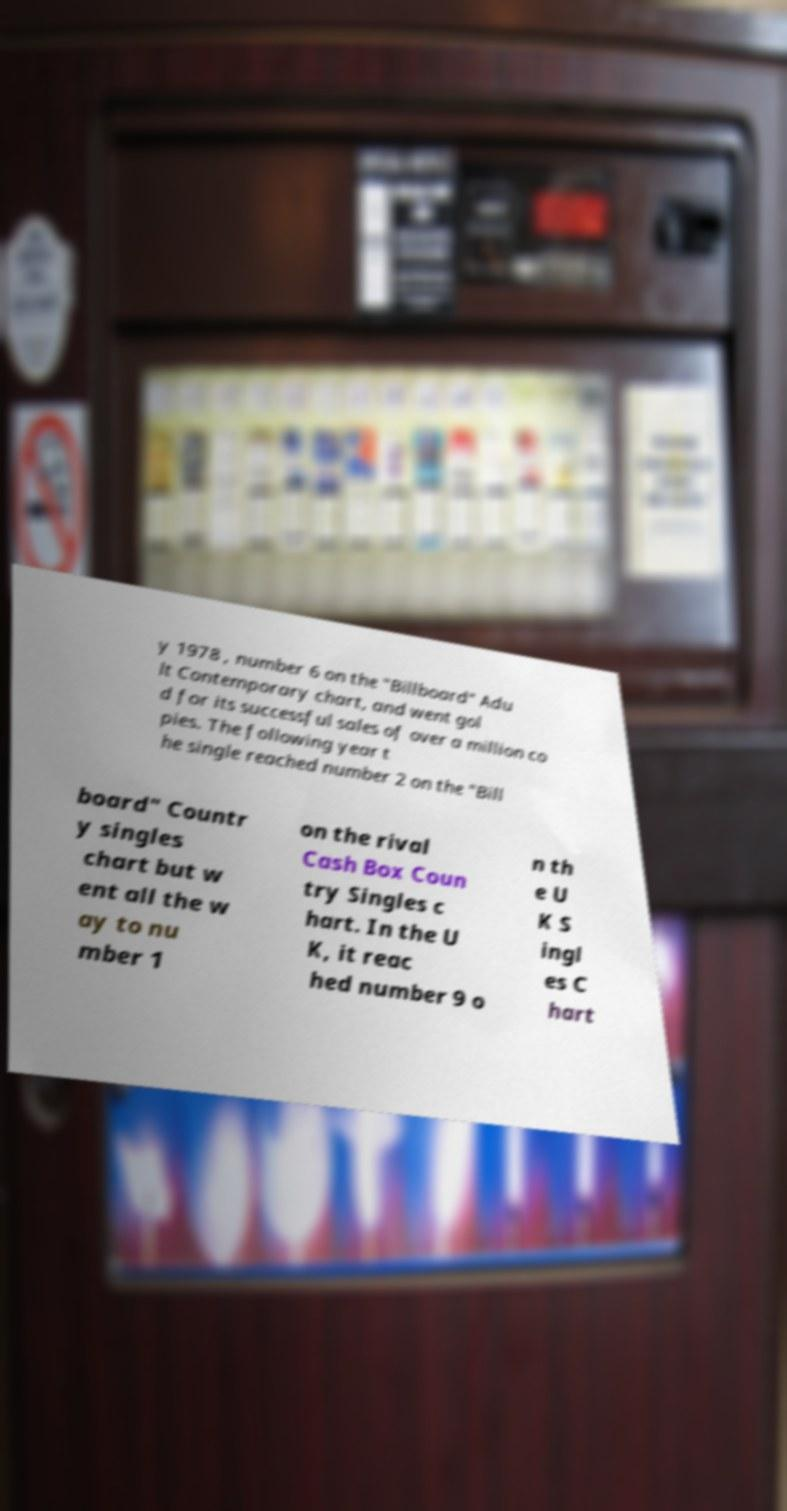Can you accurately transcribe the text from the provided image for me? y 1978 , number 6 on the "Billboard" Adu lt Contemporary chart, and went gol d for its successful sales of over a million co pies. The following year t he single reached number 2 on the "Bill board" Countr y singles chart but w ent all the w ay to nu mber 1 on the rival Cash Box Coun try Singles c hart. In the U K, it reac hed number 9 o n th e U K S ingl es C hart 